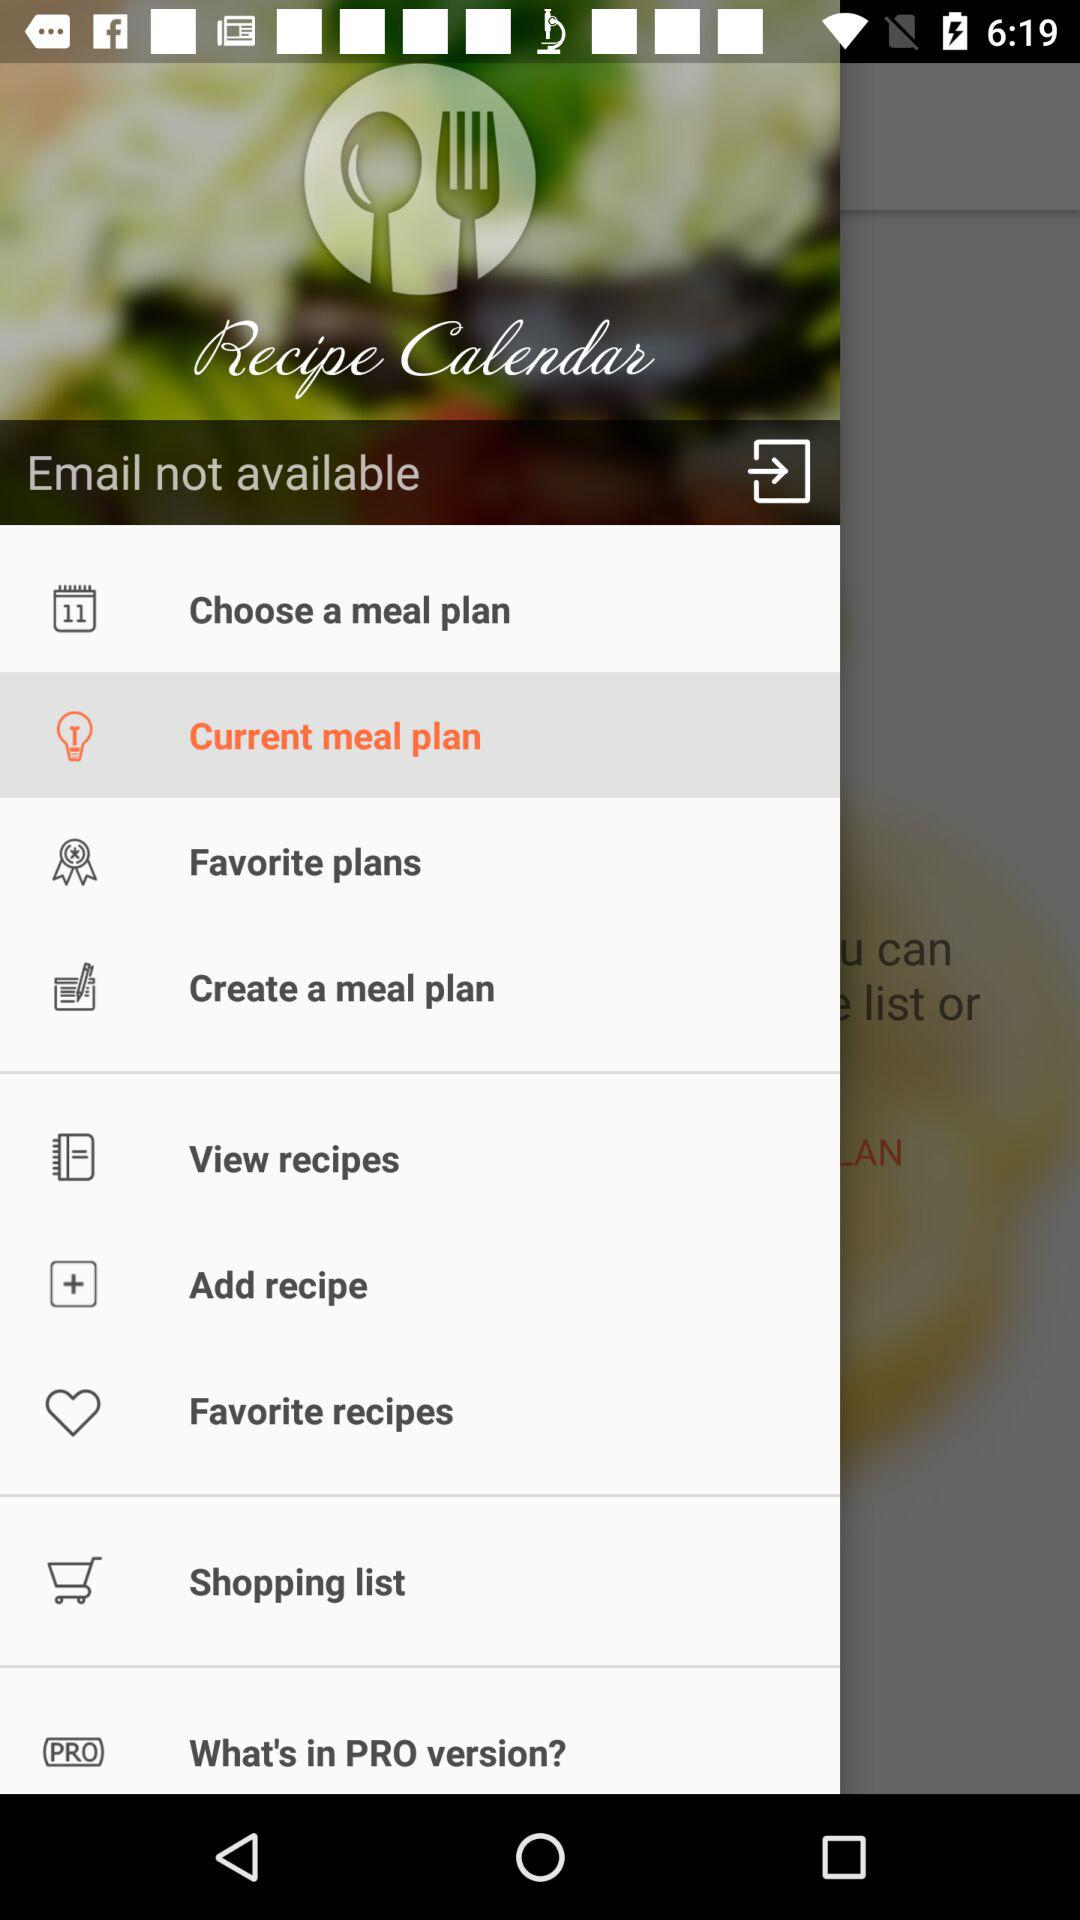What is not available? It is the email that is not available. 